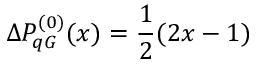Convert formula to latex. <formula><loc_0><loc_0><loc_500><loc_500>\Delta P _ { q G } ^ { ( 0 ) } ( x ) = \frac { 1 } { 2 } ( 2 x - 1 )</formula> 